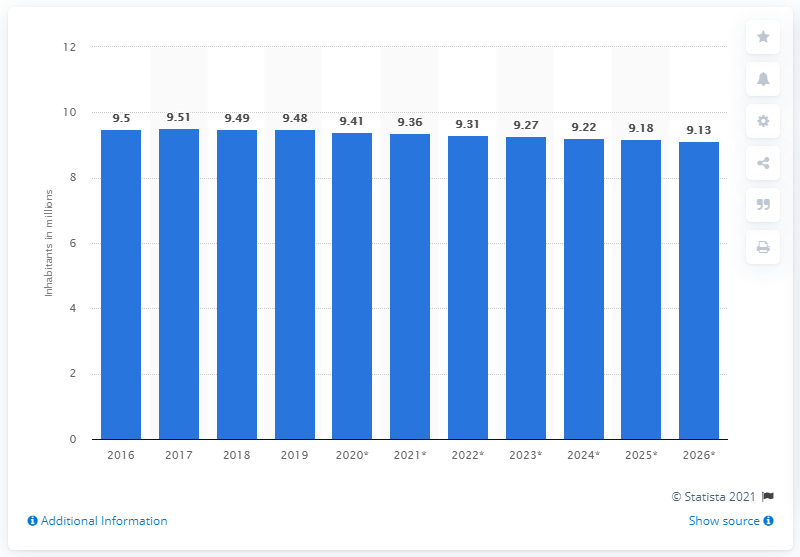Indicate a few pertinent items in this graphic. In 2019, the population of Belarus was approximately 9.41 million. 